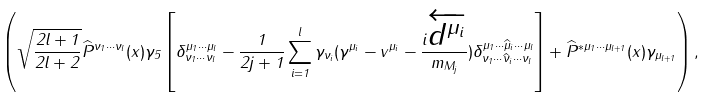<formula> <loc_0><loc_0><loc_500><loc_500>\left ( \sqrt { \frac { 2 l + 1 } { 2 l + 2 } } \widehat { P } ^ { \nu _ { 1 } \cdots \nu _ { l } } ( x ) \gamma _ { 5 } \left [ \delta _ { \nu _ { 1 } \cdots \nu _ { l } } ^ { \mu _ { 1 } \cdots \mu _ { l } } - \frac { 1 } { 2 j + 1 } \sum _ { i = 1 } ^ { l } \gamma _ { \nu _ { i } } ( \gamma ^ { \mu _ { i } } - v ^ { \mu _ { i } } - \frac { i \overleftarrow { d ^ { \mu _ { i } } } } { m _ { M _ { j } } } ) \delta _ { \nu _ { 1 } \cdots \widehat { \nu } _ { i } \cdots \nu _ { l } } ^ { \mu _ { 1 } \cdots \widehat { \mu } _ { i } \cdots \mu _ { l } } \right ] + \widehat { P } ^ { * \mu _ { 1 } \cdots \mu _ { l + 1 } } ( x ) \gamma _ { \mu _ { l + 1 } } \right ) ,</formula> 